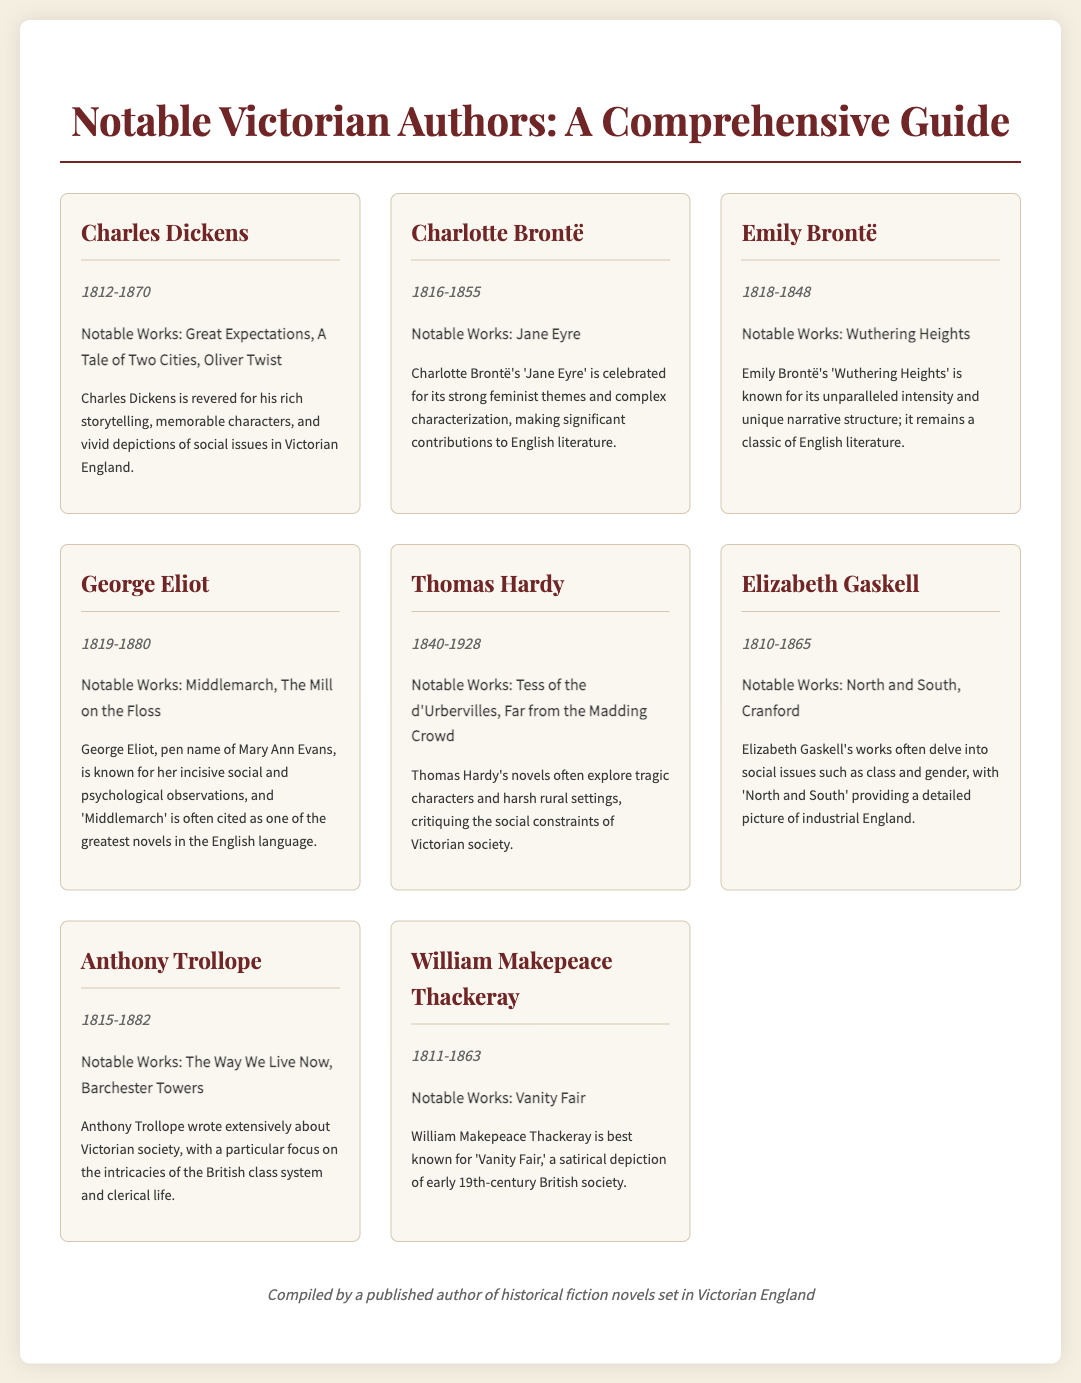What is the lifespan of Charles Dickens? The document provides the lifespan of Charles Dickens as 1812-1870.
Answer: 1812-1870 Which author is known for "Wuthering Heights"? The document states that Emily Brontë is known for "Wuthering Heights".
Answer: Emily Brontë What year did Thomas Hardy die? The document indicates that Thomas Hardy died in 1928.
Answer: 1928 Which work is associated with George Eliot? The notable works of George Eliot listed in the document include "Middlemarch".
Answer: Middlemarch How many notable works are associated with Charlotte Brontë? The document states that Charlotte Brontë has one notable work, "Jane Eyre".
Answer: One What themes does Elizabeth Gaskell's "North and South" address? The document mentions that Elizabeth Gaskell’s works delve into social issues such as class and gender.
Answer: Class and gender Who wrote "Vanity Fair"? The document attributes "Vanity Fair" to William Makepeace Thackeray.
Answer: William Makepeace Thackeray Which author is known as the pen name for Mary Ann Evans? The document specifies that George Eliot is the pen name for Mary Ann Evans.
Answer: George Eliot 